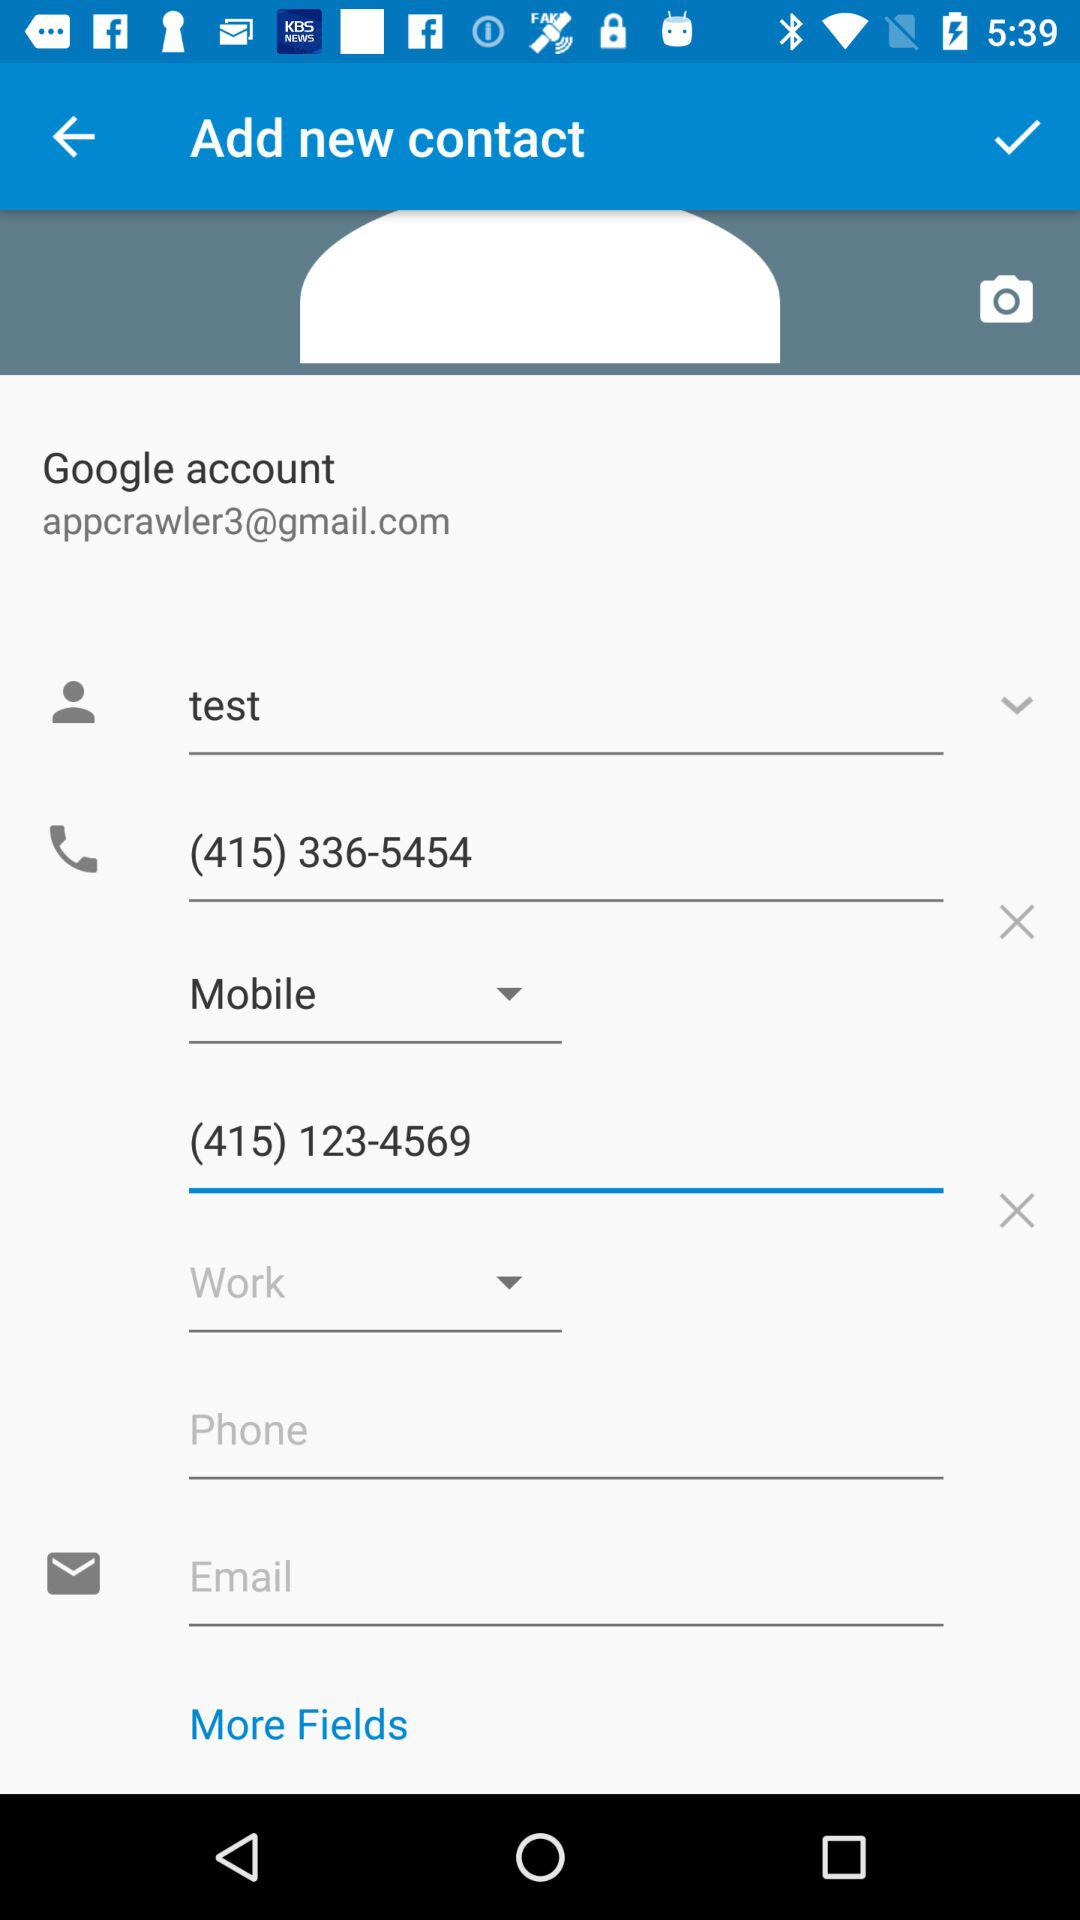How many phone numbers are there on this contact?
Answer the question using a single word or phrase. 2 